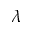Convert formula to latex. <formula><loc_0><loc_0><loc_500><loc_500>\lambda</formula> 